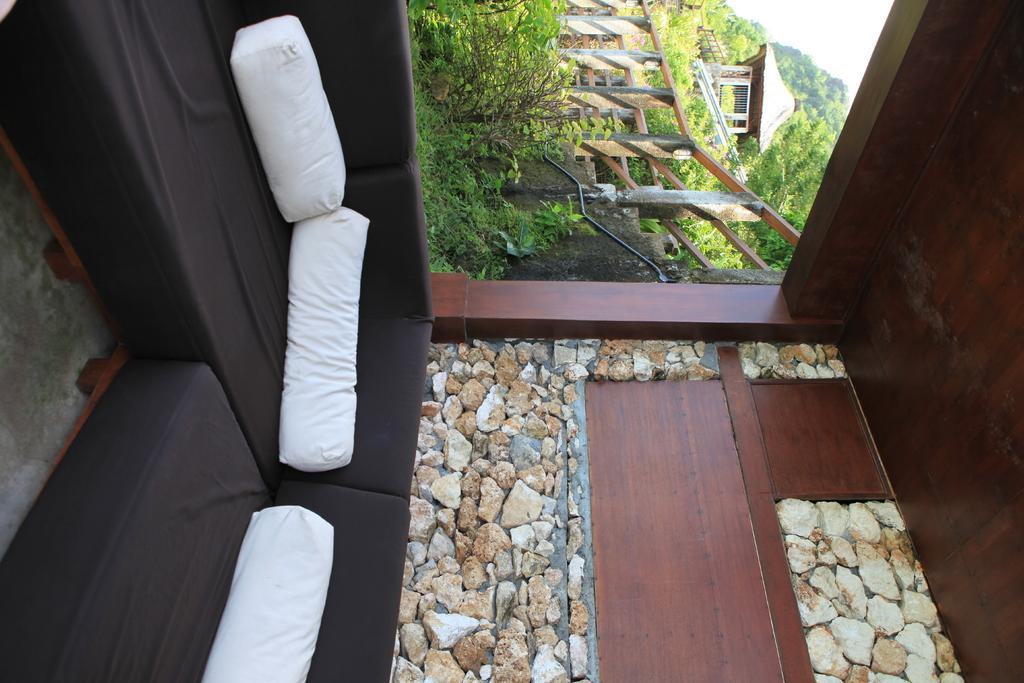What type of house is shown in the image? The image is an inside view of a wooden house. What material are the pebbles made of? The pebbles are visible in the image, but their material is not specified. What type of seating is present in the image? There is a sofa in the image. What color are the pillows on the sofa? White pillows are present in the image. What type of barrier is visible in the image? There is a fence in the image. What type of vegetation is visible in the image? Plants are visible in the image. What can be seen in the distance outside the wooden house? A wooden house is visible in the distance, along with trees. How many bees are sitting on the cushion in the image? There is no cushion or bees present in the image. What type of screw is used to hold the wooden house together? The image does not show the construction of the wooden house, so it is not possible to determine the type of screw used. 